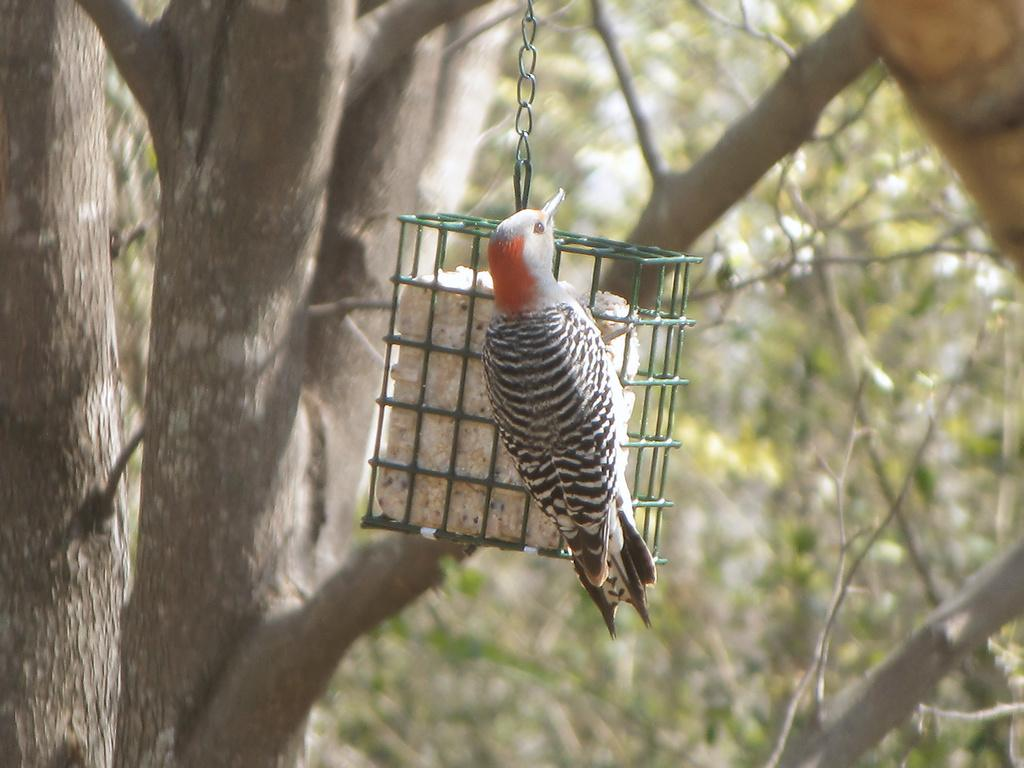What type of animal can be seen in the image? There is a bird in the image. What is the bird contained within? The bird is contained within a grill cage in the image. What is inside the cage with the bird? A food item for the bird is inside the cage. How is the cage suspended in the image? The cage is hanging with a chain. What can be seen in the background of the image? There are trees visible in the background of the image. What type of teeth can be seen on the bird in the image? Birds do not have teeth, so there are no teeth visible on the bird in the image. 